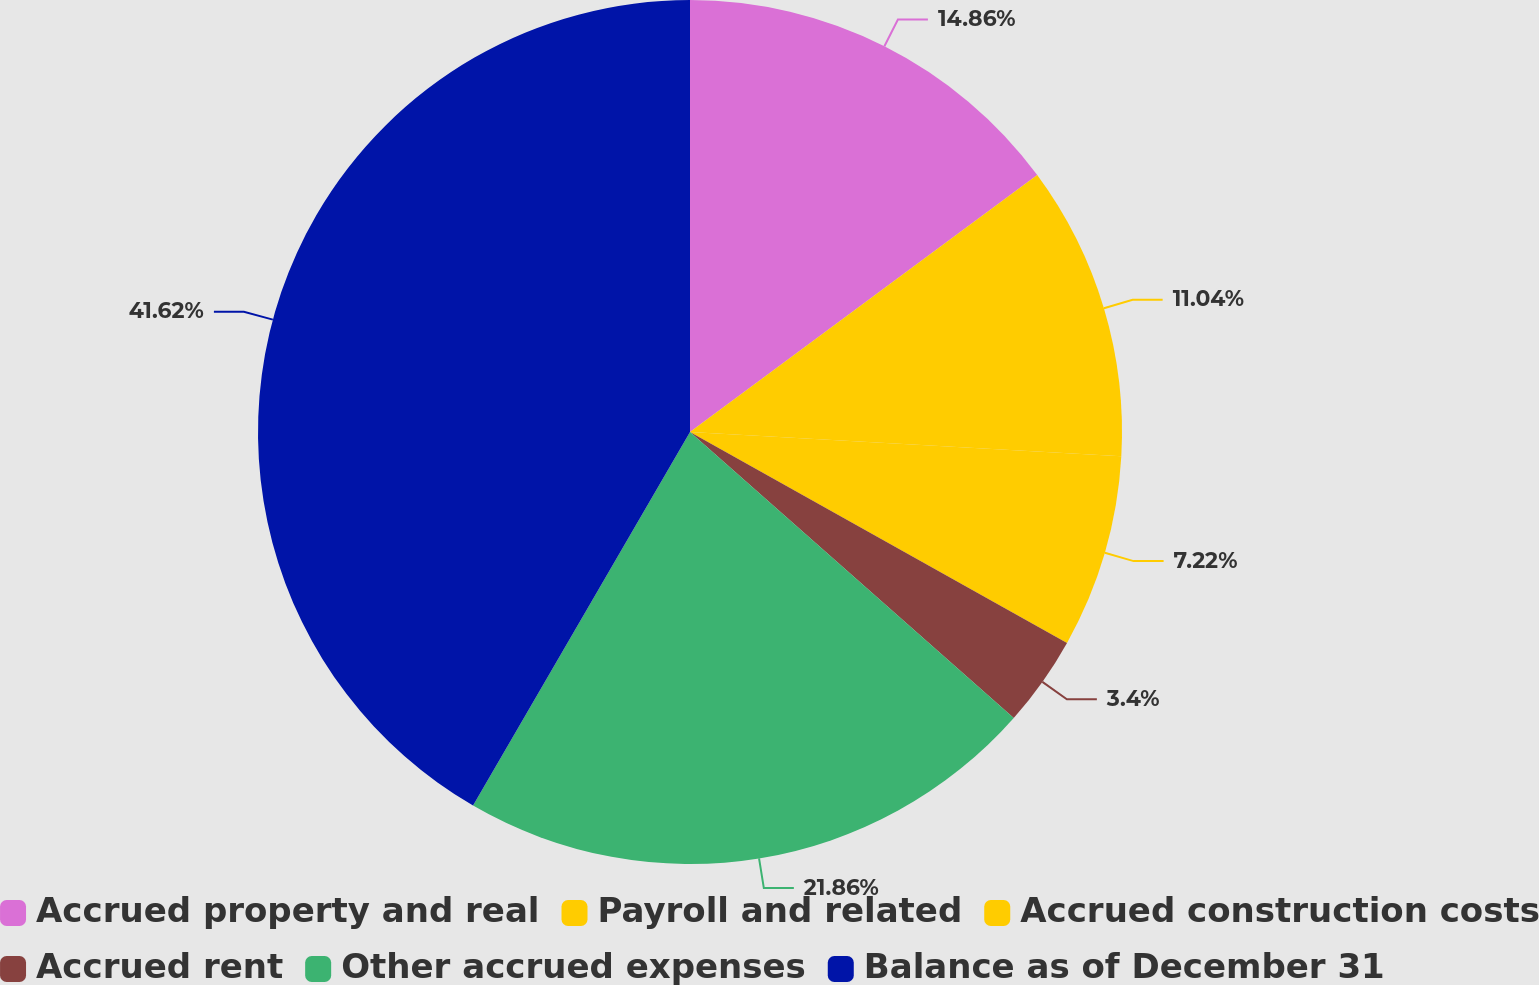<chart> <loc_0><loc_0><loc_500><loc_500><pie_chart><fcel>Accrued property and real<fcel>Payroll and related<fcel>Accrued construction costs<fcel>Accrued rent<fcel>Other accrued expenses<fcel>Balance as of December 31<nl><fcel>14.86%<fcel>11.04%<fcel>7.22%<fcel>3.4%<fcel>21.86%<fcel>41.63%<nl></chart> 